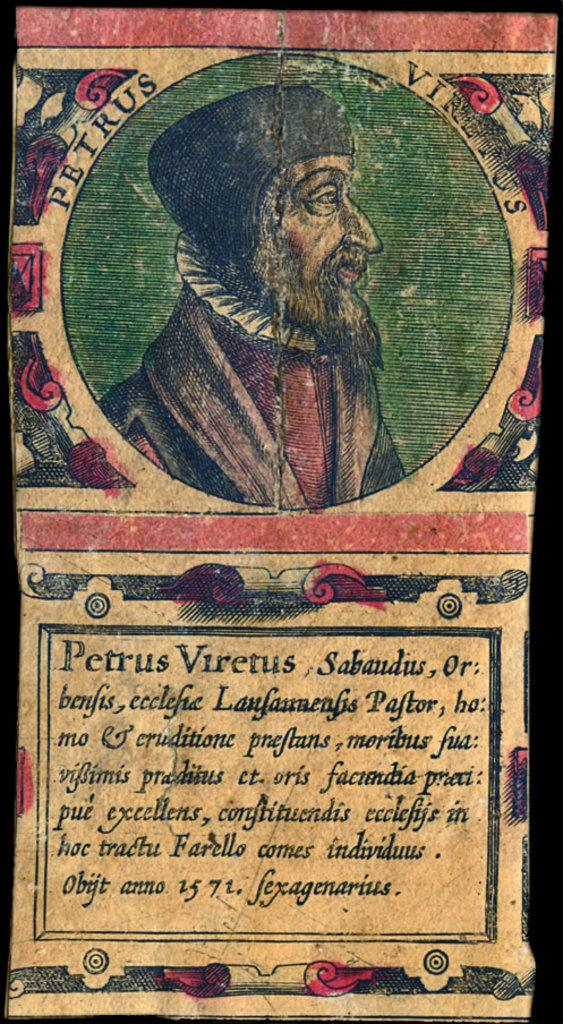What is the medium of the image? The image is on a paper. What is depicted in the image on the paper? There is an image of a person on the paper. Are there any additional elements on the paper besides the image? Yes, there is writing on the paper. What type of book is the person holding in the image? There is no book present in the image; it only features an image of a person and writing on the paper. 